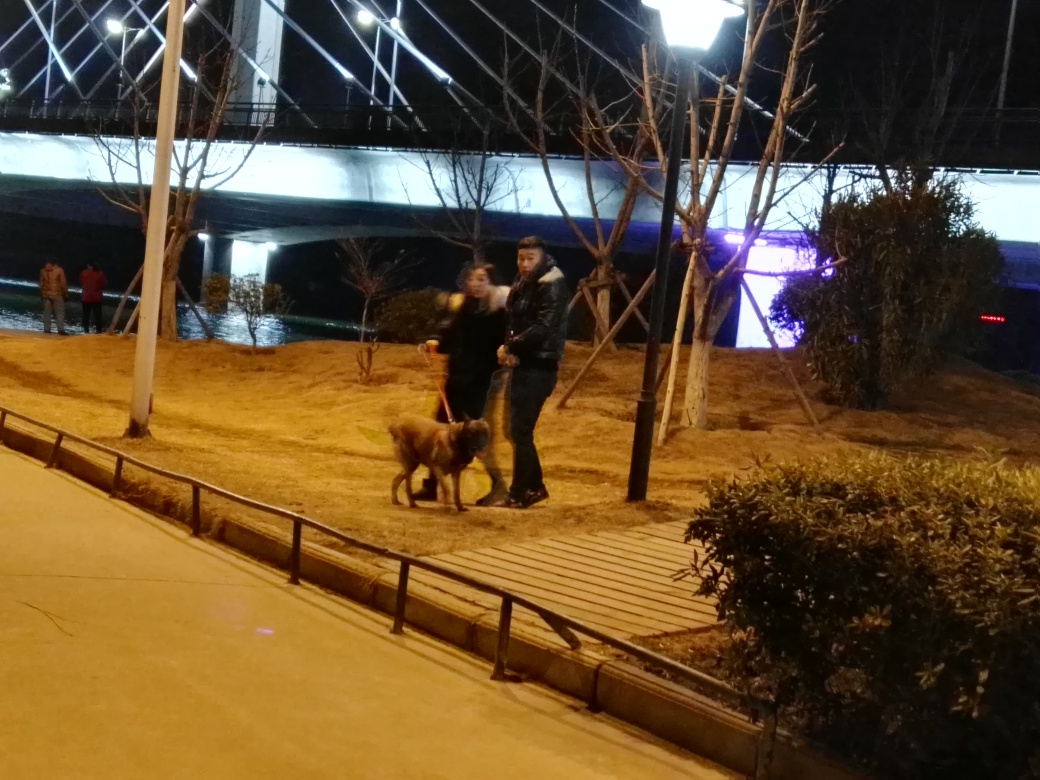Can you describe the ambient atmosphere in this location? The setting conveys a serene evening atmosphere, possibly in an urban park or riverside walkway, where people and a dog are enjoying a leisurely stroll amidst the soft glow of street lights. Does the location seem busy or quiet? Based on the image, the location seems relatively quiet with only a few people visible, suggesting a peaceful setting rather than a bustling environment. 